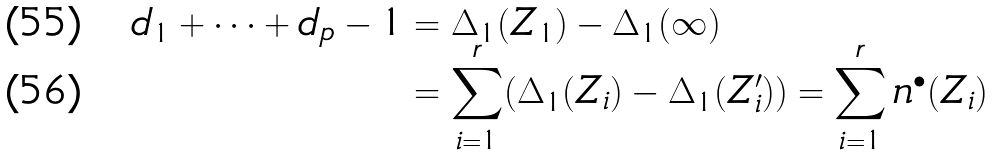Convert formula to latex. <formula><loc_0><loc_0><loc_500><loc_500>d _ { 1 } + \dots + d _ { p } - 1 & = \Delta _ { 1 } ( Z _ { 1 } ) - \Delta _ { 1 } ( \infty ) \\ & = \sum _ { i = 1 } ^ { r } ( \Delta _ { 1 } ( Z _ { i } ) - \Delta _ { 1 } ( Z ^ { \prime } _ { i } ) ) = \sum _ { i = 1 } ^ { r } n ^ { \bullet } ( Z _ { i } )</formula> 